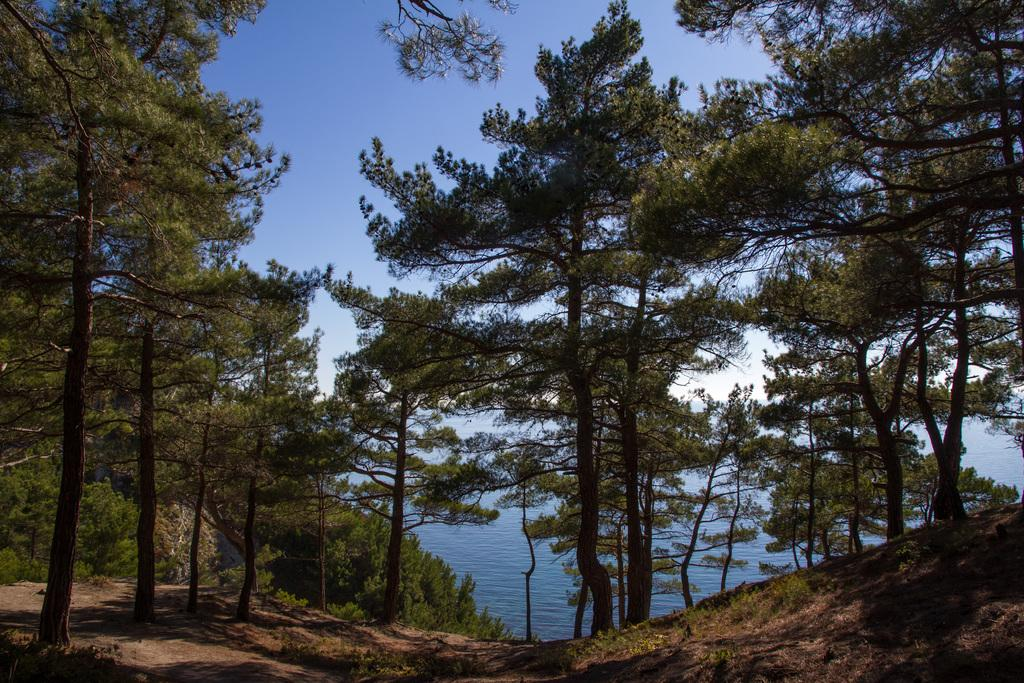What type of vegetation can be seen in the image? There are trees in the image. What can be seen in the background of the image? There is water and the sky visible in the background of the image. What type of veil is draped over the trees in the image? There is no veil present in the image; it features trees, water, and the sky. 